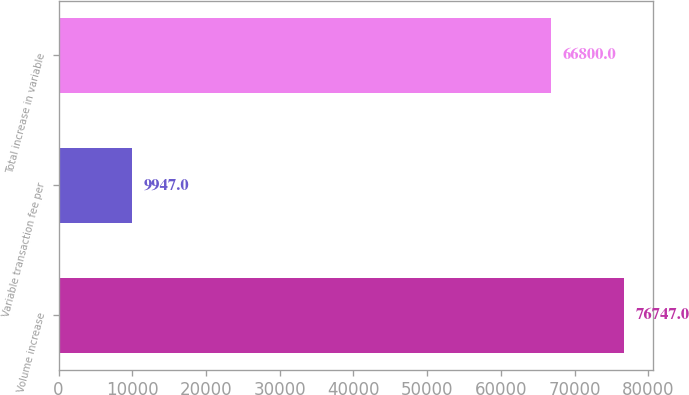<chart> <loc_0><loc_0><loc_500><loc_500><bar_chart><fcel>Volume increase<fcel>Variable transaction fee per<fcel>Total increase in variable<nl><fcel>76747<fcel>9947<fcel>66800<nl></chart> 